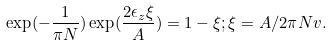<formula> <loc_0><loc_0><loc_500><loc_500>\exp ( - \frac { 1 } { \pi N } ) \exp ( \frac { 2 \epsilon _ { z } \xi } { A } ) = 1 - \xi ; \/ \/ \xi = A / 2 \pi N v .</formula> 